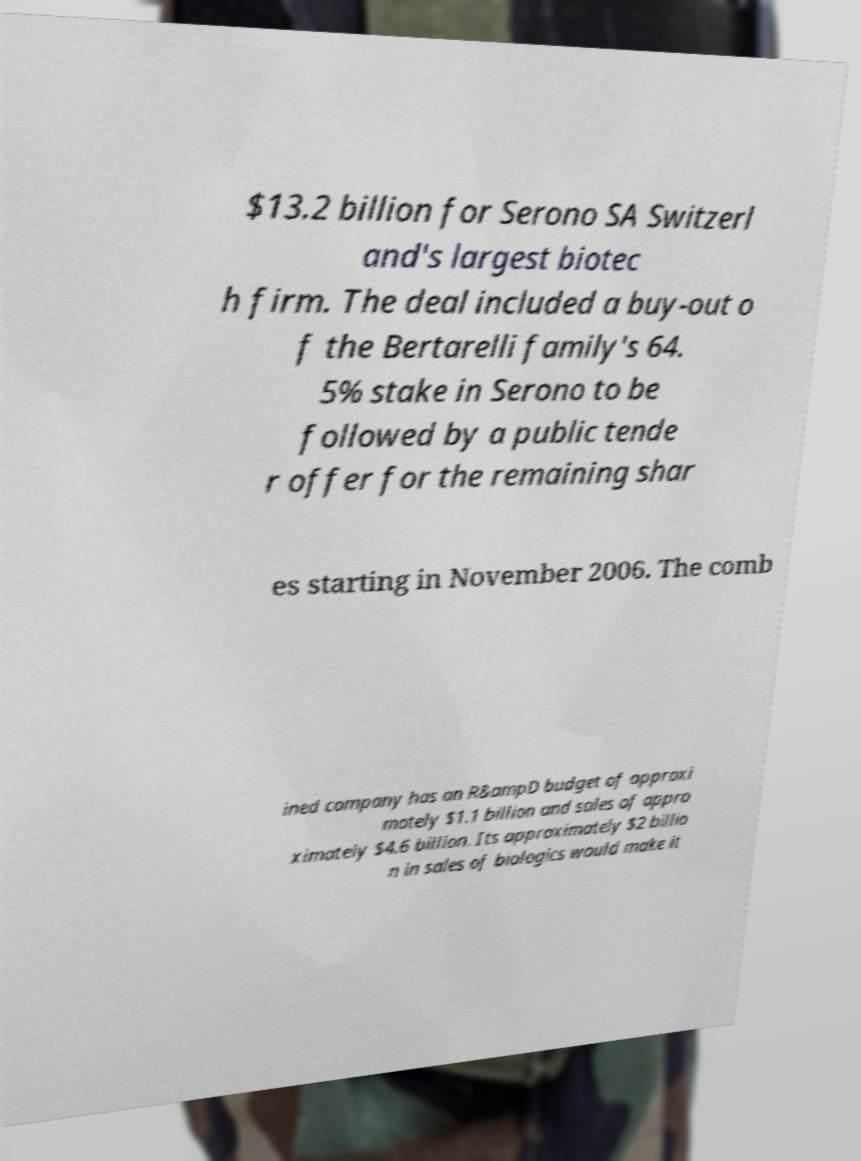There's text embedded in this image that I need extracted. Can you transcribe it verbatim? $13.2 billion for Serono SA Switzerl and's largest biotec h firm. The deal included a buy-out o f the Bertarelli family's 64. 5% stake in Serono to be followed by a public tende r offer for the remaining shar es starting in November 2006. The comb ined company has an R&ampD budget of approxi mately $1.1 billion and sales of appro ximately $4.6 billion. Its approximately $2 billio n in sales of biologics would make it 